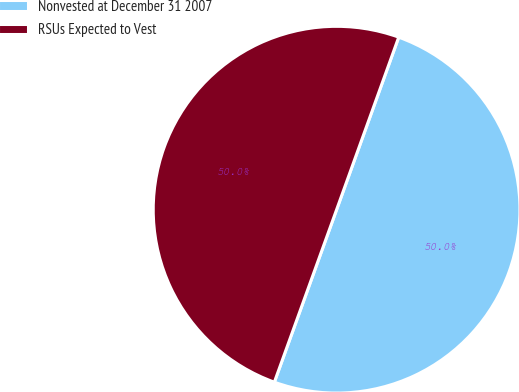<chart> <loc_0><loc_0><loc_500><loc_500><pie_chart><fcel>Nonvested at December 31 2007<fcel>RSUs Expected to Vest<nl><fcel>50.01%<fcel>49.99%<nl></chart> 